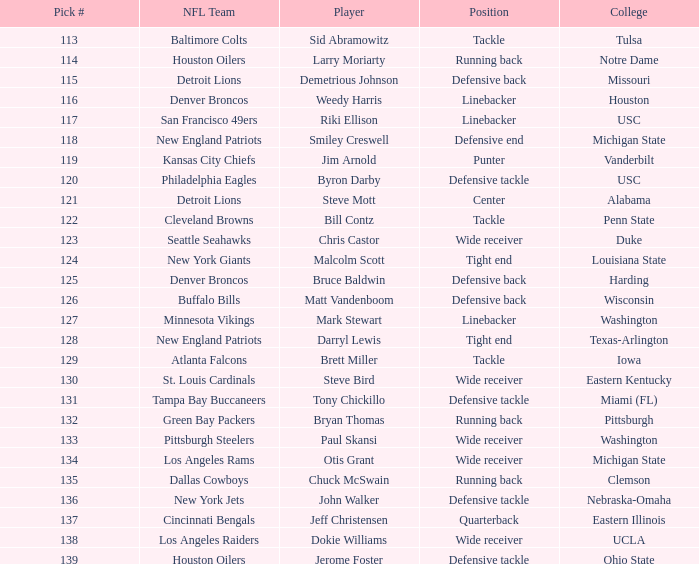What is the highest pick number the los angeles raiders got? 138.0. 